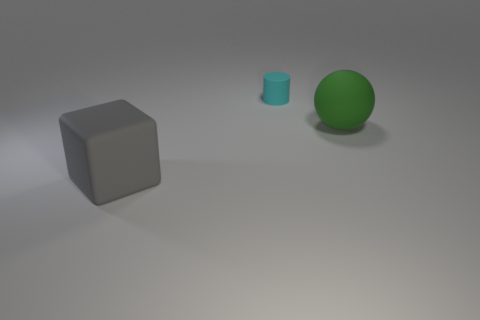How big is the rubber thing that is behind the gray cube and in front of the small cyan matte thing?
Your answer should be compact. Large. Is there any other thing of the same color as the ball?
Keep it short and to the point. No. There is a tiny cyan thing that is the same material as the big gray block; what shape is it?
Provide a succinct answer. Cylinder. There is a cyan thing; does it have the same shape as the large matte object on the left side of the large green matte ball?
Offer a terse response. No. What is the big thing that is behind the big matte thing left of the big matte sphere made of?
Offer a terse response. Rubber. Are there the same number of gray objects that are left of the tiny cyan matte cylinder and big red rubber spheres?
Provide a succinct answer. No. Are there any other things that have the same material as the large sphere?
Your response must be concise. Yes. There is a large object that is in front of the large matte sphere; is it the same color as the matte object to the right of the cyan object?
Your response must be concise. No. What number of large rubber things are both on the left side of the matte cylinder and behind the gray cube?
Your answer should be very brief. 0. How many other objects are there of the same shape as the small cyan rubber object?
Ensure brevity in your answer.  0. 